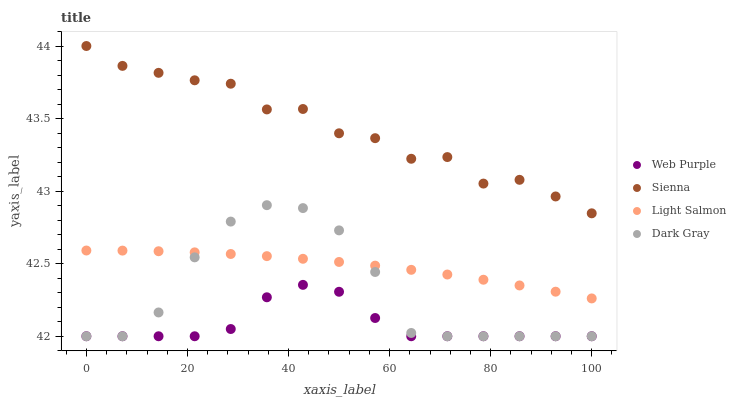Does Web Purple have the minimum area under the curve?
Answer yes or no. Yes. Does Sienna have the maximum area under the curve?
Answer yes or no. Yes. Does Dark Gray have the minimum area under the curve?
Answer yes or no. No. Does Dark Gray have the maximum area under the curve?
Answer yes or no. No. Is Light Salmon the smoothest?
Answer yes or no. Yes. Is Dark Gray the roughest?
Answer yes or no. Yes. Is Web Purple the smoothest?
Answer yes or no. No. Is Web Purple the roughest?
Answer yes or no. No. Does Dark Gray have the lowest value?
Answer yes or no. Yes. Does Light Salmon have the lowest value?
Answer yes or no. No. Does Sienna have the highest value?
Answer yes or no. Yes. Does Dark Gray have the highest value?
Answer yes or no. No. Is Web Purple less than Light Salmon?
Answer yes or no. Yes. Is Sienna greater than Dark Gray?
Answer yes or no. Yes. Does Dark Gray intersect Light Salmon?
Answer yes or no. Yes. Is Dark Gray less than Light Salmon?
Answer yes or no. No. Is Dark Gray greater than Light Salmon?
Answer yes or no. No. Does Web Purple intersect Light Salmon?
Answer yes or no. No. 